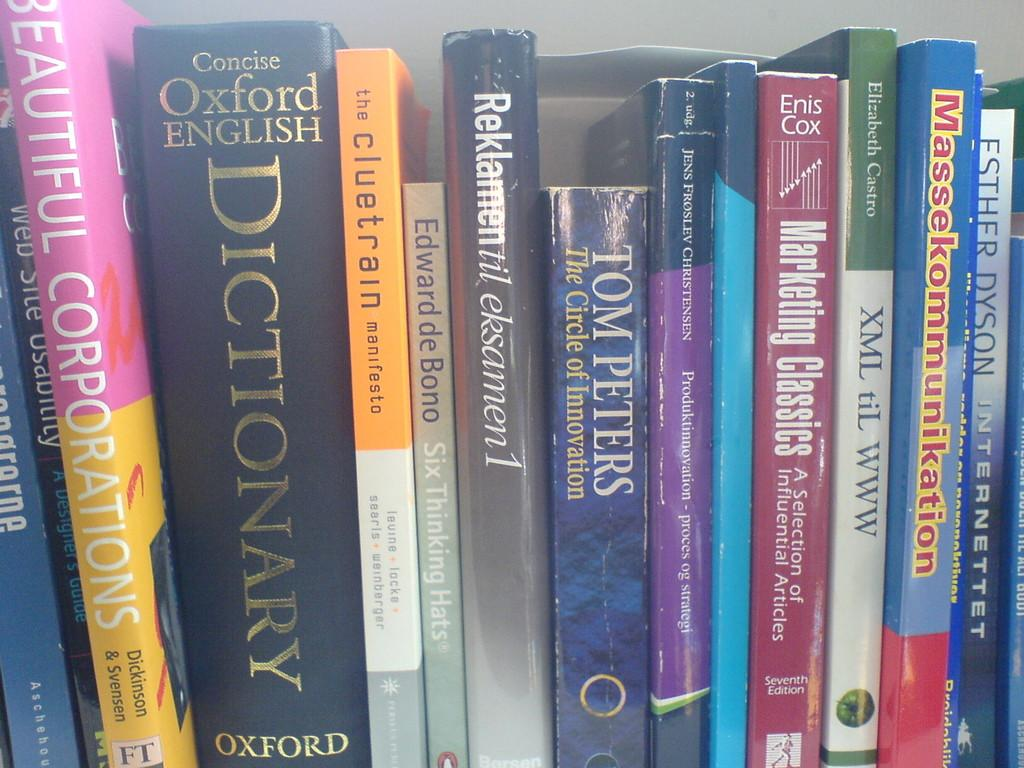Provide a one-sentence caption for the provided image. a stack of books on a shelf like Tom Peters and Beautiful Corporations. 